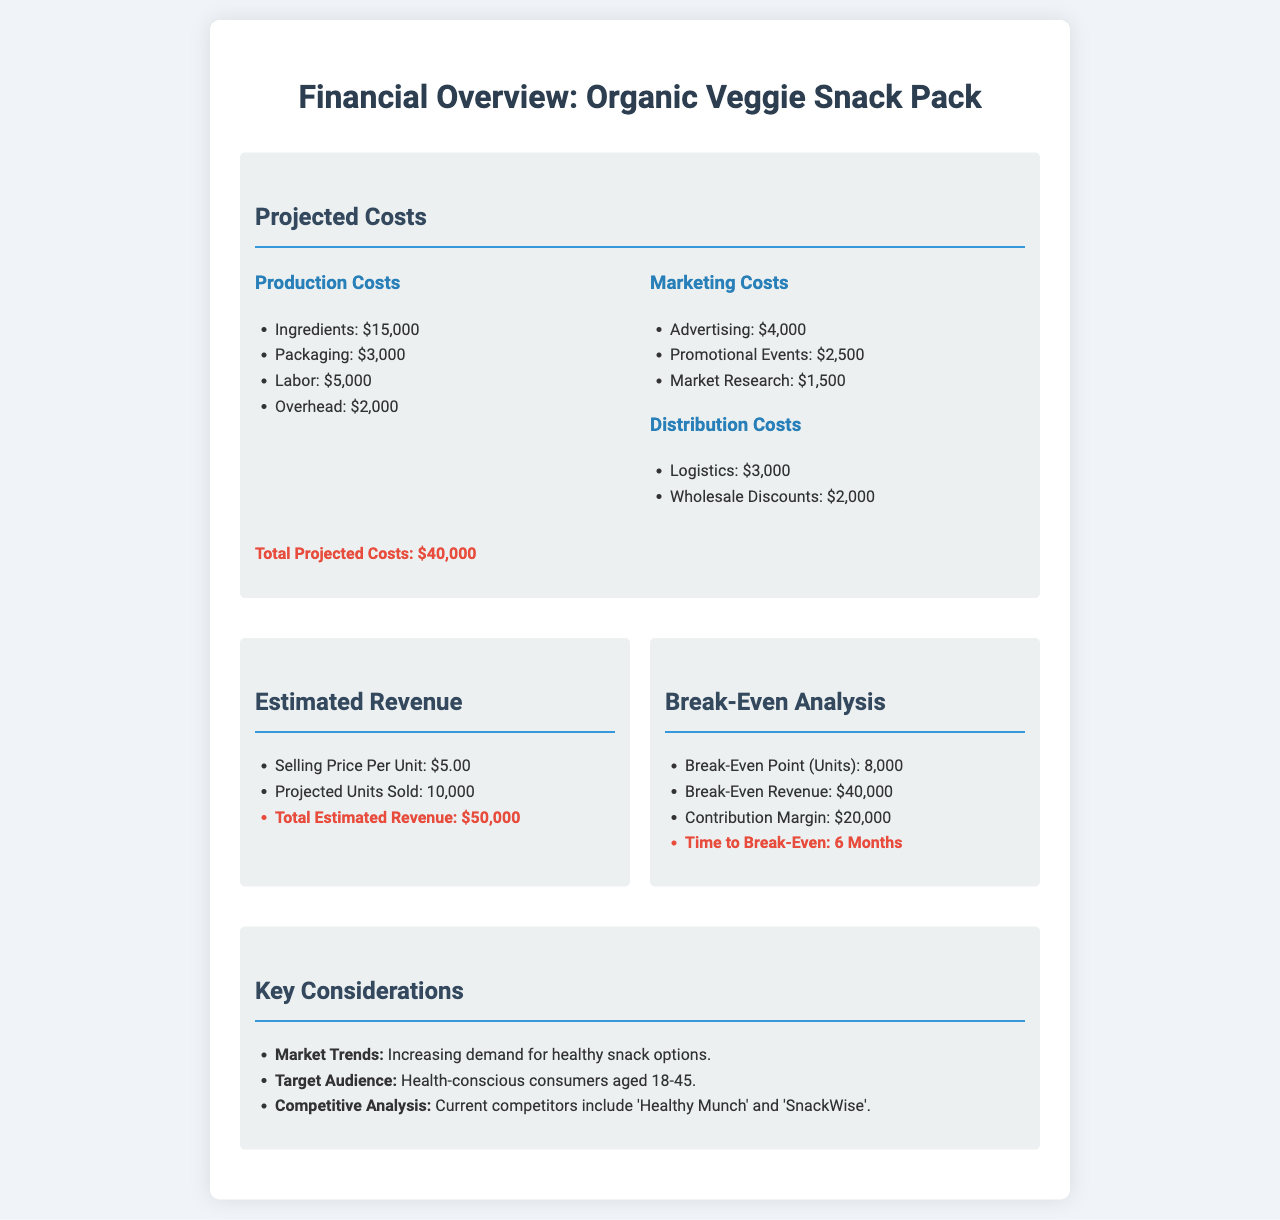What are the total projected costs? The total projected costs are provided at the end of the projected costs section, which is $40,000.
Answer: $40,000 What is the selling price per unit? The selling price per unit is stated in the estimated revenue section as $5.00.
Answer: $5.00 How many units need to be sold to break even? The break-even point in units, stated in the break-even analysis section, is 8,000.
Answer: 8,000 What are the total estimated revenues? Total estimated revenue is calculated based on projected units sold, which is $50,000 as mentioned in the document.
Answer: $50,000 What is the time to break-even? The time required to break even is listed in the break-even analysis as 6 months.
Answer: 6 Months What are the ingredients costs? The ingredients costs are mentioned under production costs as $15,000.
Answer: $15,000 What is the contribution margin? The contribution margin is indicated in the break-even analysis section as $20,000.
Answer: $20,000 Who are the main competitors mentioned? The competitive analysis states that current competitors include 'Healthy Munch' and 'SnackWise'.
Answer: Healthy Munch, SnackWise 